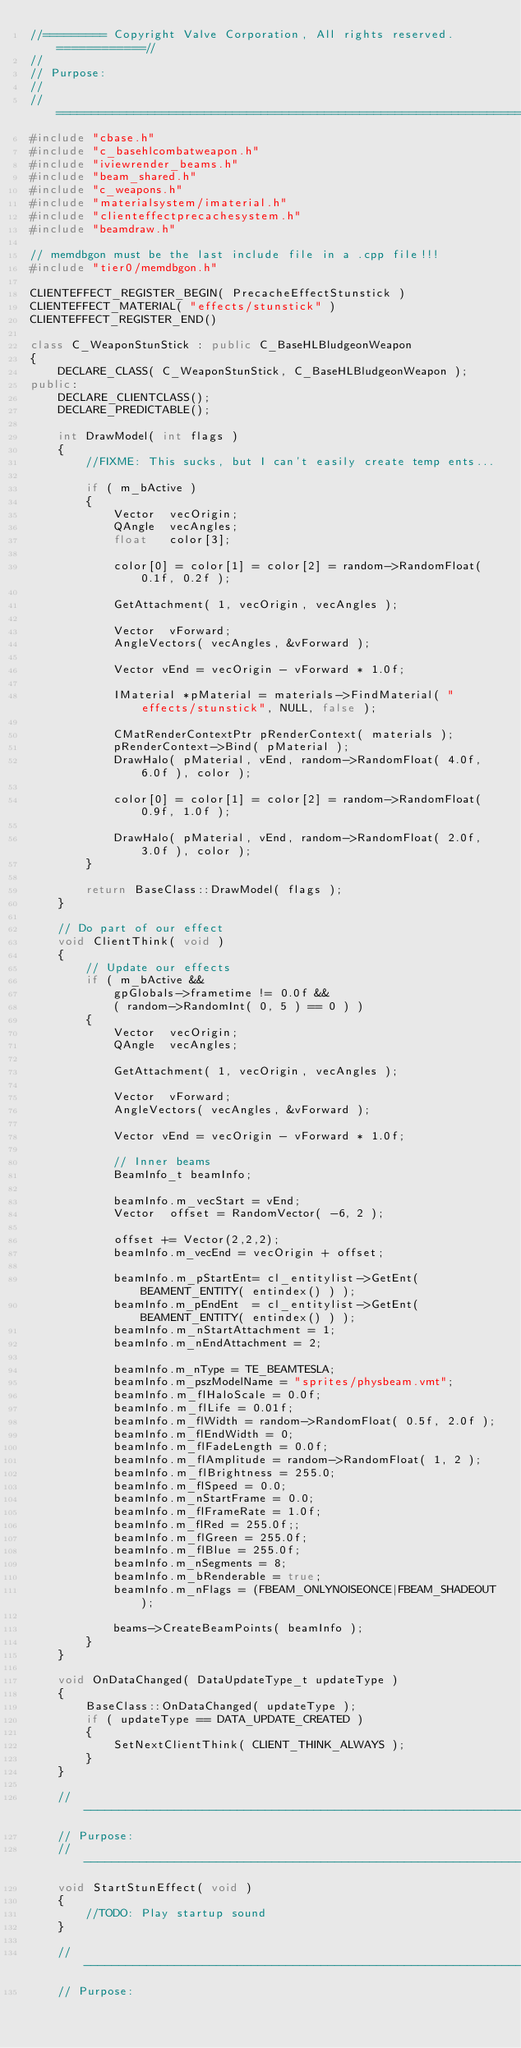Convert code to text. <code><loc_0><loc_0><loc_500><loc_500><_C++_>//========= Copyright Valve Corporation, All rights reserved. ============//
//
// Purpose:
//
//=============================================================================//
#include "cbase.h"
#include "c_basehlcombatweapon.h"
#include "iviewrender_beams.h"
#include "beam_shared.h"
#include "c_weapons.h"
#include "materialsystem/imaterial.h"
#include "clienteffectprecachesystem.h"
#include "beamdraw.h"

// memdbgon must be the last include file in a .cpp file!!!
#include "tier0/memdbgon.h"

CLIENTEFFECT_REGISTER_BEGIN( PrecacheEffectStunstick )
CLIENTEFFECT_MATERIAL( "effects/stunstick" )
CLIENTEFFECT_REGISTER_END()

class C_WeaponStunStick : public C_BaseHLBludgeonWeapon
{
    DECLARE_CLASS( C_WeaponStunStick, C_BaseHLBludgeonWeapon );
public:
    DECLARE_CLIENTCLASS();
    DECLARE_PREDICTABLE();

    int DrawModel( int flags )
    {
        //FIXME: This sucks, but I can't easily create temp ents...

        if ( m_bActive )
        {
            Vector  vecOrigin;
            QAngle  vecAngles;
            float   color[3];

            color[0] = color[1] = color[2] = random->RandomFloat( 0.1f, 0.2f );

            GetAttachment( 1, vecOrigin, vecAngles );

            Vector  vForward;
            AngleVectors( vecAngles, &vForward );

            Vector vEnd = vecOrigin - vForward * 1.0f;

            IMaterial *pMaterial = materials->FindMaterial( "effects/stunstick", NULL, false );

            CMatRenderContextPtr pRenderContext( materials );
            pRenderContext->Bind( pMaterial );
            DrawHalo( pMaterial, vEnd, random->RandomFloat( 4.0f, 6.0f ), color );

            color[0] = color[1] = color[2] = random->RandomFloat( 0.9f, 1.0f );

            DrawHalo( pMaterial, vEnd, random->RandomFloat( 2.0f, 3.0f ), color );
        }

        return BaseClass::DrawModel( flags );
    }

    // Do part of our effect
    void ClientThink( void )
    {
        // Update our effects
        if ( m_bActive &&
            gpGlobals->frametime != 0.0f &&
            ( random->RandomInt( 0, 5 ) == 0 ) )
        {
            Vector  vecOrigin;
            QAngle  vecAngles;

            GetAttachment( 1, vecOrigin, vecAngles );

            Vector  vForward;
            AngleVectors( vecAngles, &vForward );

            Vector vEnd = vecOrigin - vForward * 1.0f;

            // Inner beams
            BeamInfo_t beamInfo;

            beamInfo.m_vecStart = vEnd;
            Vector  offset = RandomVector( -6, 2 );

            offset += Vector(2,2,2);
            beamInfo.m_vecEnd = vecOrigin + offset;

            beamInfo.m_pStartEnt= cl_entitylist->GetEnt( BEAMENT_ENTITY( entindex() ) );
            beamInfo.m_pEndEnt  = cl_entitylist->GetEnt( BEAMENT_ENTITY( entindex() ) );
            beamInfo.m_nStartAttachment = 1;
            beamInfo.m_nEndAttachment = 2;

            beamInfo.m_nType = TE_BEAMTESLA;
            beamInfo.m_pszModelName = "sprites/physbeam.vmt";
            beamInfo.m_flHaloScale = 0.0f;
            beamInfo.m_flLife = 0.01f;
            beamInfo.m_flWidth = random->RandomFloat( 0.5f, 2.0f );
            beamInfo.m_flEndWidth = 0;
            beamInfo.m_flFadeLength = 0.0f;
            beamInfo.m_flAmplitude = random->RandomFloat( 1, 2 );
            beamInfo.m_flBrightness = 255.0;
            beamInfo.m_flSpeed = 0.0;
            beamInfo.m_nStartFrame = 0.0;
            beamInfo.m_flFrameRate = 1.0f;
            beamInfo.m_flRed = 255.0f;;
            beamInfo.m_flGreen = 255.0f;
            beamInfo.m_flBlue = 255.0f;
            beamInfo.m_nSegments = 8;
            beamInfo.m_bRenderable = true;
            beamInfo.m_nFlags = (FBEAM_ONLYNOISEONCE|FBEAM_SHADEOUT);

            beams->CreateBeamPoints( beamInfo );
        }
    }

    void OnDataChanged( DataUpdateType_t updateType )
    {
        BaseClass::OnDataChanged( updateType );
        if ( updateType == DATA_UPDATE_CREATED )
        {
            SetNextClientThink( CLIENT_THINK_ALWAYS );
        }
    }

    //-----------------------------------------------------------------------------
    // Purpose:
    //-----------------------------------------------------------------------------
    void StartStunEffect( void )
    {
        //TODO: Play startup sound
    }

    //-----------------------------------------------------------------------------
    // Purpose:</code> 